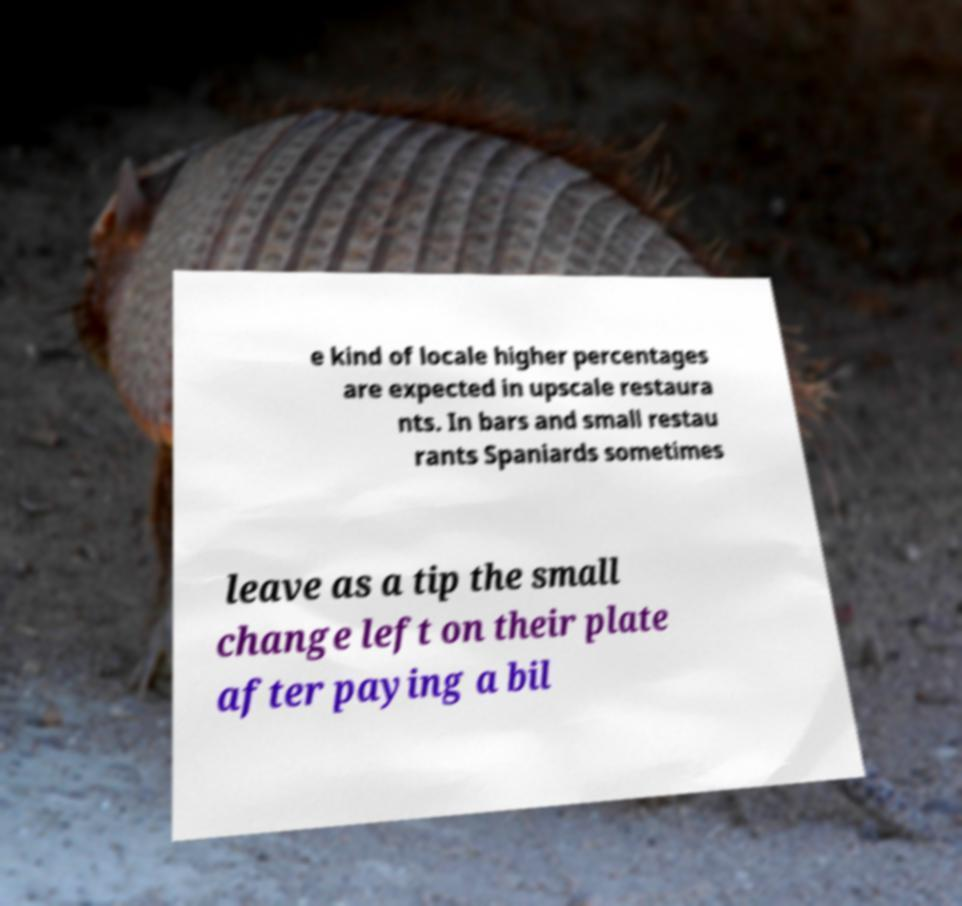For documentation purposes, I need the text within this image transcribed. Could you provide that? e kind of locale higher percentages are expected in upscale restaura nts. In bars and small restau rants Spaniards sometimes leave as a tip the small change left on their plate after paying a bil 